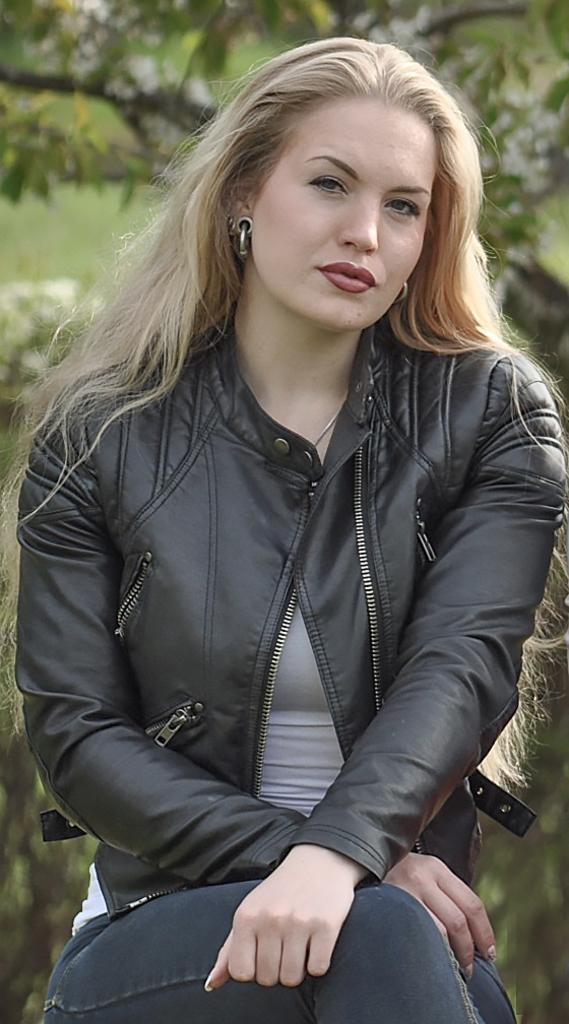Who is the main subject in the image? There is a woman in the image. What is the woman doing in the image? The woman is sitting and taking a picture. What type of government is depicted in the image? There is no depiction of a government in the image; it features a woman sitting and taking a picture. What tool is the woman using to gather leaves in the image? There is no tool or activity related to gathering leaves in the image. 